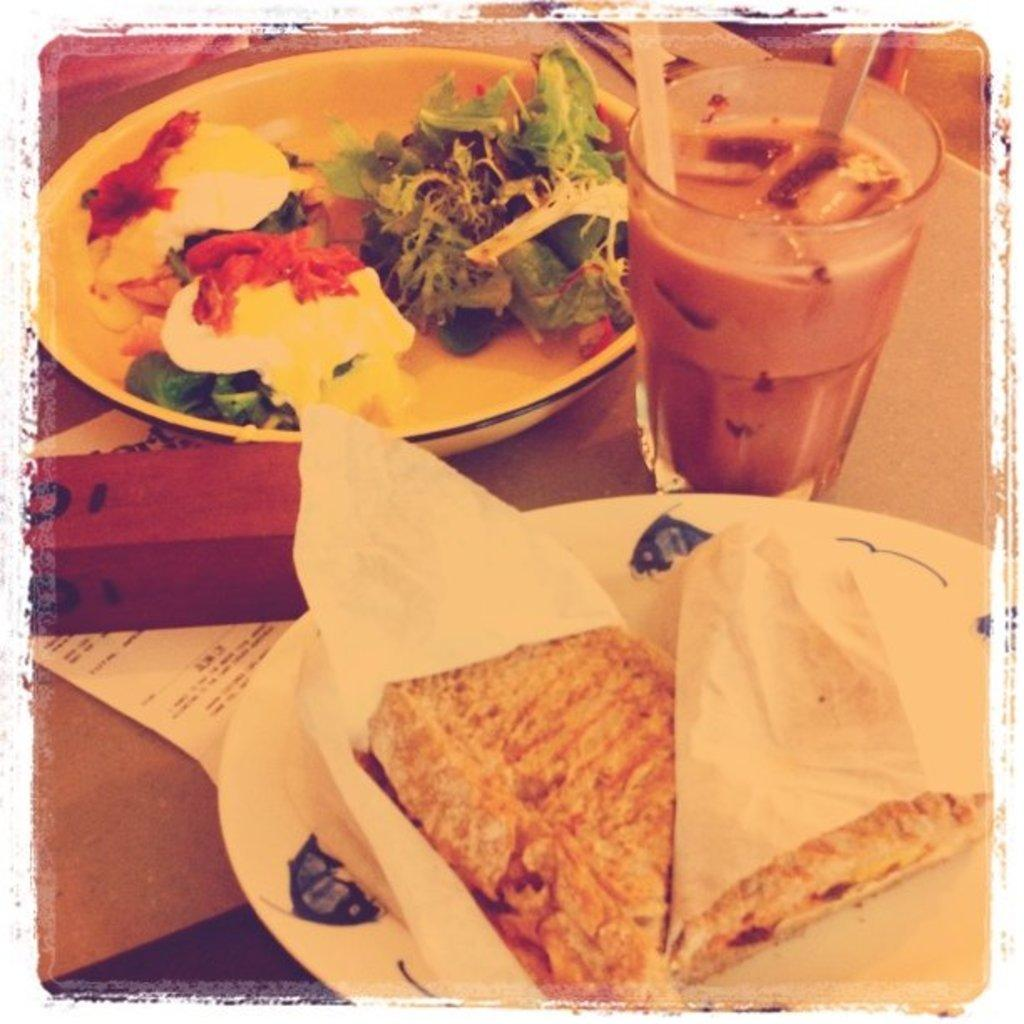What is the main piece of furniture in the image? There is a table in the image. What food items can be seen on the table? One plate contains a sandwich and the other plate contains a salad. What type of beverage is on the table? There is a glass of milkshake on the table. What is the paper on the table used for? The purpose of the paper on the table is not specified in the image. Can you describe the object on the table? The object on the table is not described in detail in the image. Where is the faucet located in the image? There is no faucet present in the image. What type of paint is used on the table in the image? The image does not provide information about the paint used on the table, if any. 